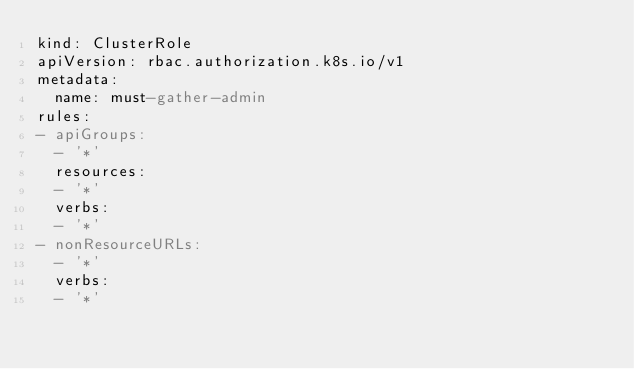<code> <loc_0><loc_0><loc_500><loc_500><_YAML_>kind: ClusterRole
apiVersion: rbac.authorization.k8s.io/v1
metadata:
  name: must-gather-admin
rules:
- apiGroups:
  - '*'
  resources:
  - '*'
  verbs:
  - '*'
- nonResourceURLs:
  - '*'
  verbs:
  - '*'
</code> 